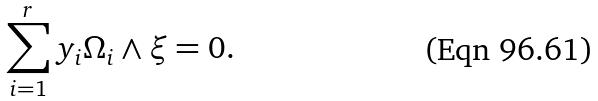Convert formula to latex. <formula><loc_0><loc_0><loc_500><loc_500>\sum _ { i = 1 } ^ { r } y _ { i } \Omega _ { i } \wedge \xi = 0 .</formula> 